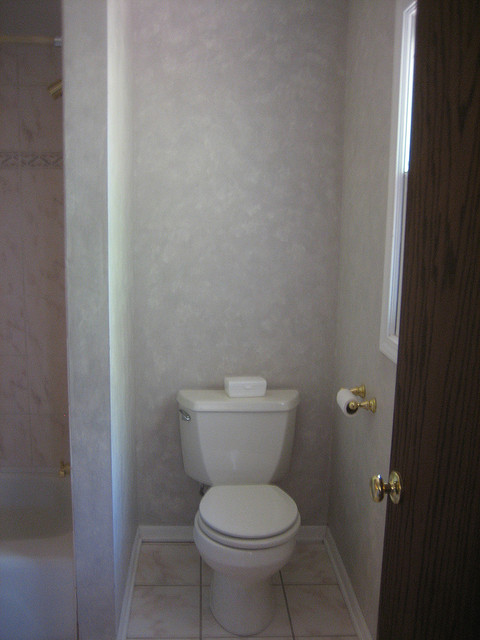<image>Where is the brush to clean the toilet? I don't know where the brush to clean the toilet is, as it's not in the picture. It could be in a closet. Where is the brush to clean the toilet? It is unknown where the brush to clean the toilet is located. It cannot be seen in the picture. 